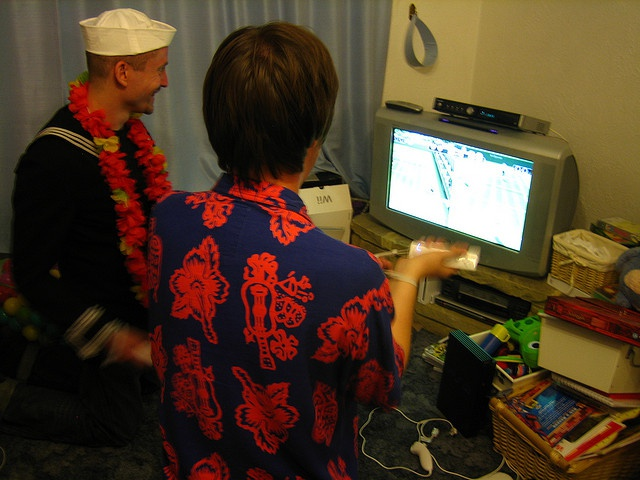Describe the objects in this image and their specific colors. I can see people in black, maroon, brown, and red tones, people in black, maroon, and tan tones, tv in black, white, darkgreen, and gray tones, book in black, maroon, blue, and olive tones, and book in black, olive, and maroon tones in this image. 